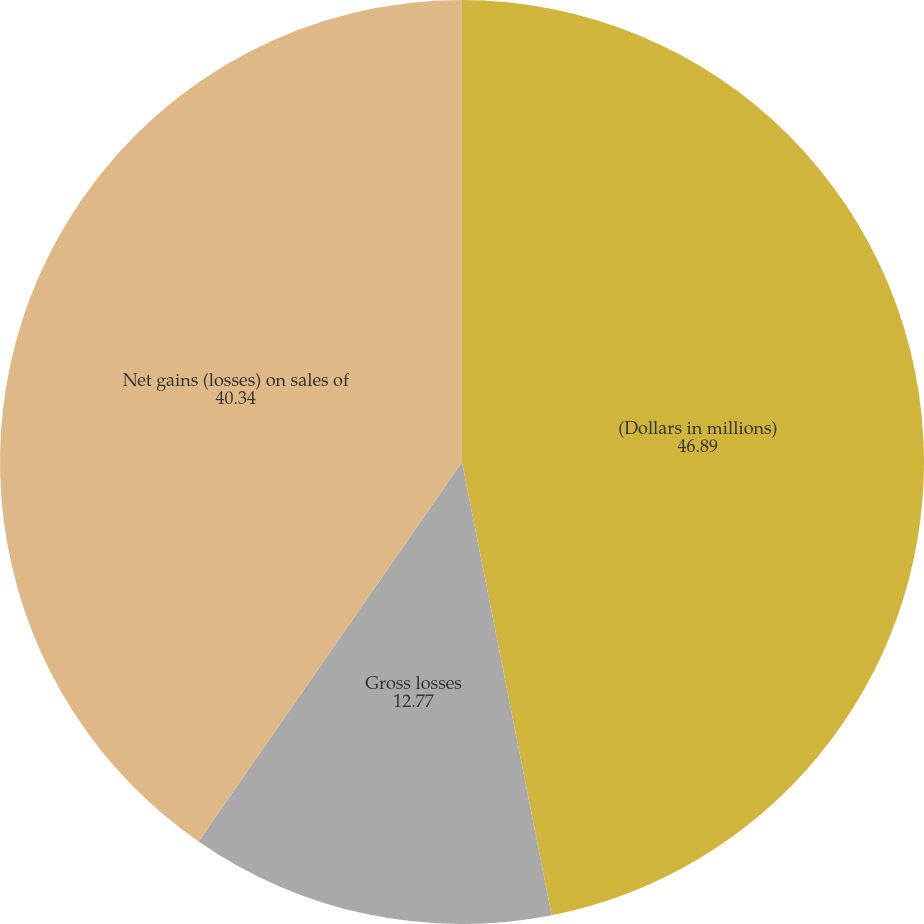<chart> <loc_0><loc_0><loc_500><loc_500><pie_chart><fcel>(Dollars in millions)<fcel>Gross losses<fcel>Net gains (losses) on sales of<nl><fcel>46.89%<fcel>12.77%<fcel>40.34%<nl></chart> 